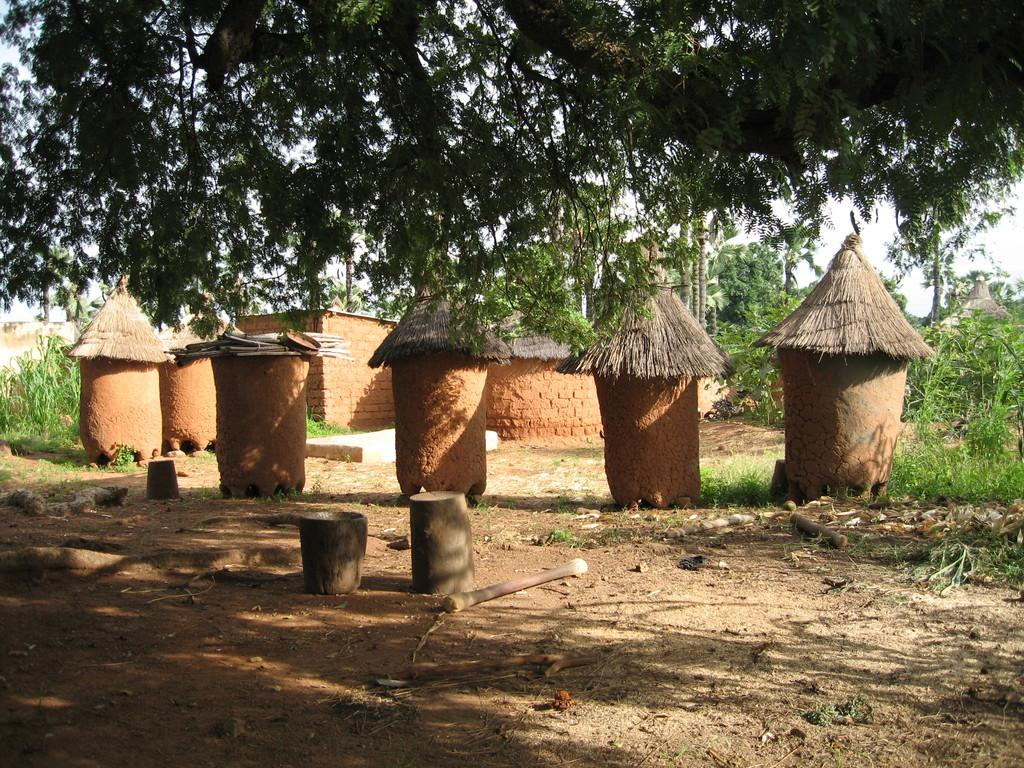What is located in the middle of the image? There are trees in the middle of the image. What can be seen at the top of the image? There are trees at the top of the image. What type of drum can be seen in the image? There is no drum present in the image; it only features trees in the middle and at the top. 